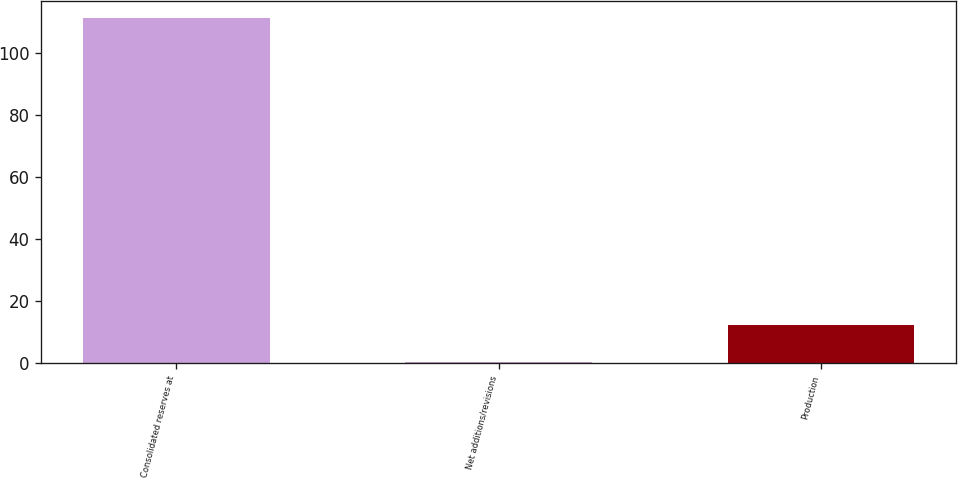Convert chart to OTSL. <chart><loc_0><loc_0><loc_500><loc_500><bar_chart><fcel>Consolidated reserves at<fcel>Net additions/revisions<fcel>Production<nl><fcel>111.2<fcel>0.5<fcel>12.42<nl></chart> 